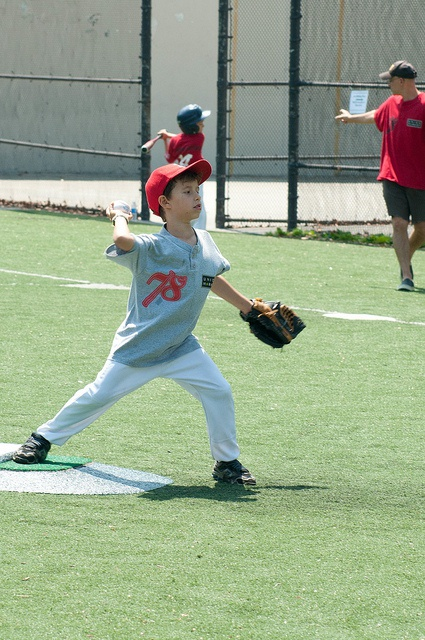Describe the objects in this image and their specific colors. I can see people in darkgray, gray, and lightblue tones, people in darkgray, maroon, black, and gray tones, baseball glove in darkgray, black, maroon, and lightgreen tones, people in darkgray, maroon, black, and darkblue tones, and sports ball in darkgray and white tones in this image. 